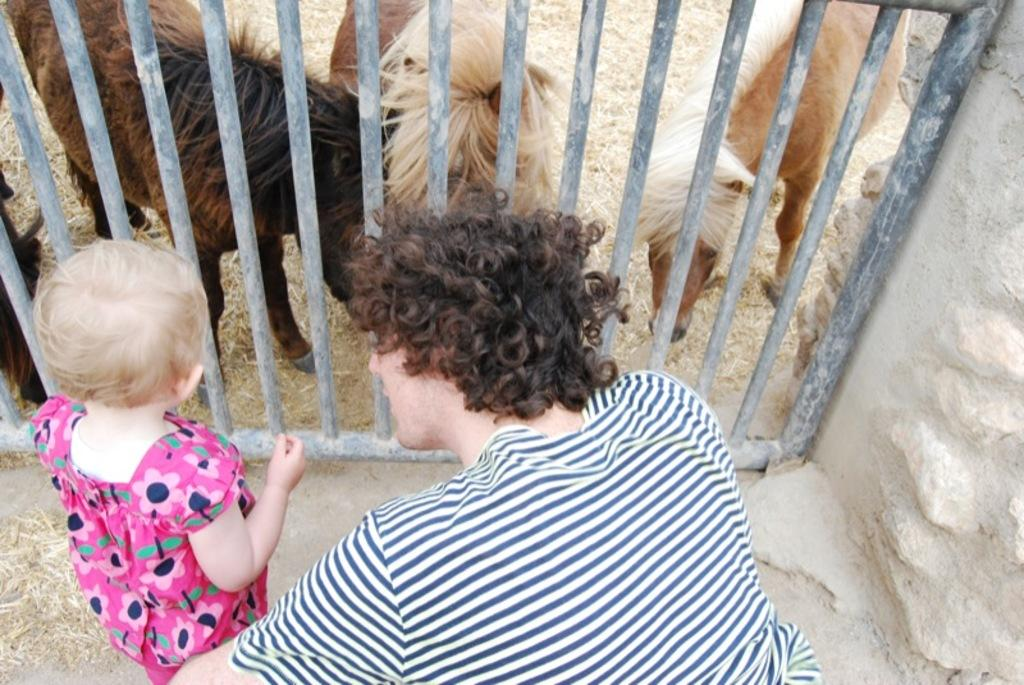How many people are visible in the image? There are two persons in the front of the image. What is located in the center of the image? There is a fence in the center of the image. What animals are behind the fence? There are goats behind the fence. Can you tell me how deep the river is in the image? There is no river present in the image; it features a fence and goats. What type of ink is being used to write on the window in the image? There is no window or writing present in the image. 